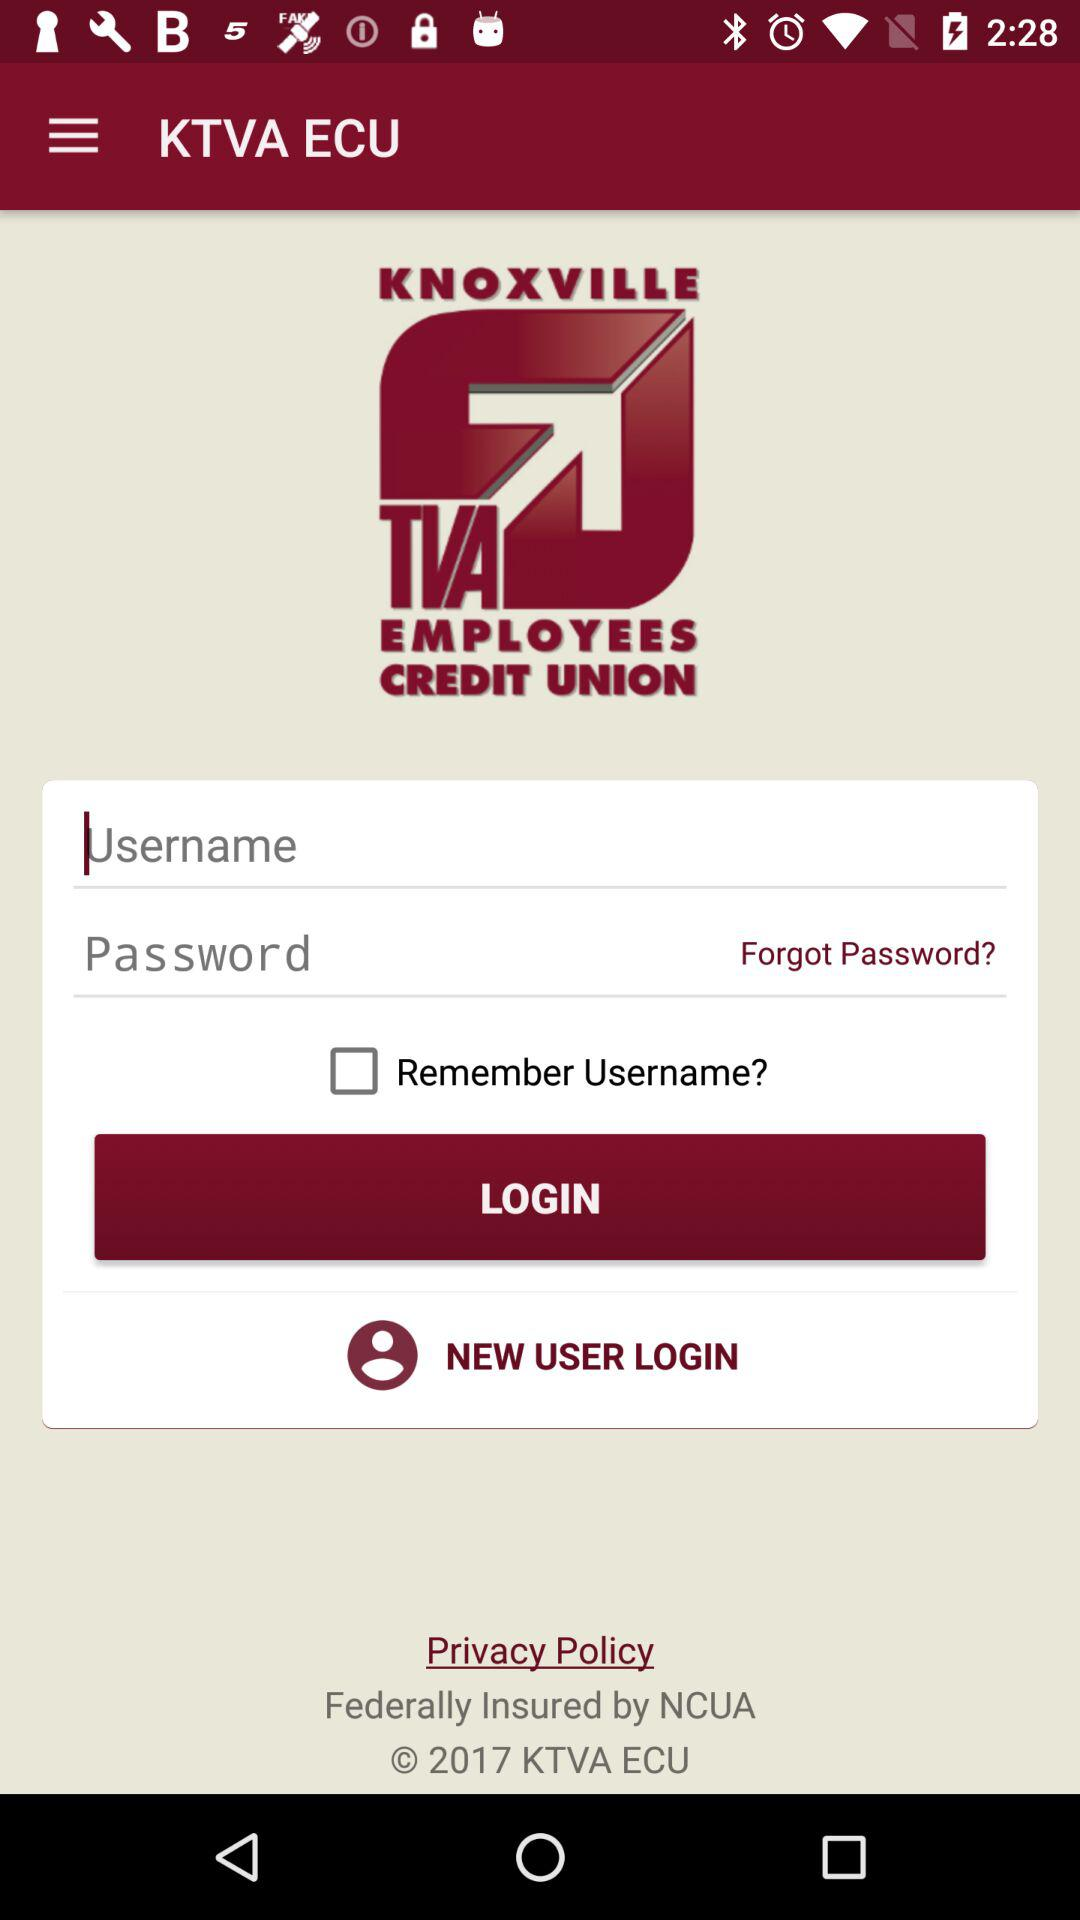What's the status of "Remember Username?"? The status is "off". 